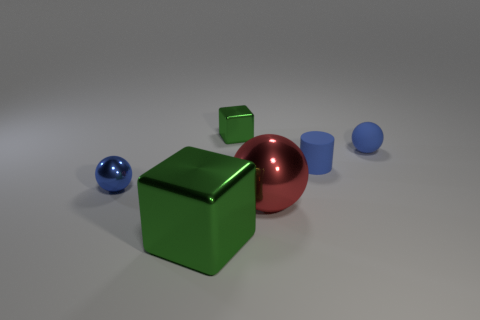Is the number of cylinders that are in front of the large cube less than the number of tiny blue objects that are to the left of the tiny blue rubber sphere? Indeed, when examining the spatial arrangement of the objects, the cylinders positioned ahead of the large green cube are fewer in number compared to the petite blue objects situated to the left of the small blue sphere. Specifically, there is one cylinder in front of the cube, whilst there are two small blue objects, a cylinder and a cube, to the left of the sphere. 